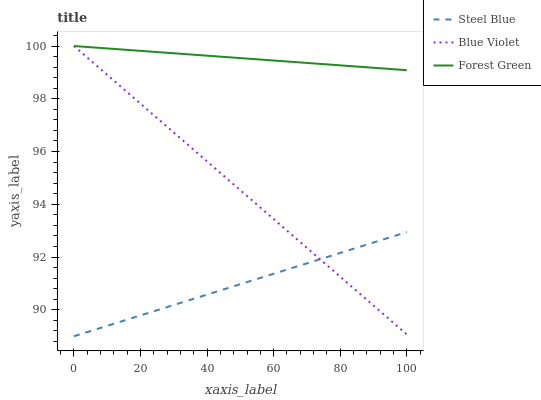Does Steel Blue have the minimum area under the curve?
Answer yes or no. Yes. Does Forest Green have the maximum area under the curve?
Answer yes or no. Yes. Does Blue Violet have the minimum area under the curve?
Answer yes or no. No. Does Blue Violet have the maximum area under the curve?
Answer yes or no. No. Is Steel Blue the smoothest?
Answer yes or no. Yes. Is Blue Violet the roughest?
Answer yes or no. Yes. Is Blue Violet the smoothest?
Answer yes or no. No. Is Steel Blue the roughest?
Answer yes or no. No. Does Steel Blue have the lowest value?
Answer yes or no. Yes. Does Blue Violet have the lowest value?
Answer yes or no. No. Does Blue Violet have the highest value?
Answer yes or no. Yes. Does Steel Blue have the highest value?
Answer yes or no. No. Is Steel Blue less than Forest Green?
Answer yes or no. Yes. Is Forest Green greater than Steel Blue?
Answer yes or no. Yes. Does Steel Blue intersect Blue Violet?
Answer yes or no. Yes. Is Steel Blue less than Blue Violet?
Answer yes or no. No. Is Steel Blue greater than Blue Violet?
Answer yes or no. No. Does Steel Blue intersect Forest Green?
Answer yes or no. No. 